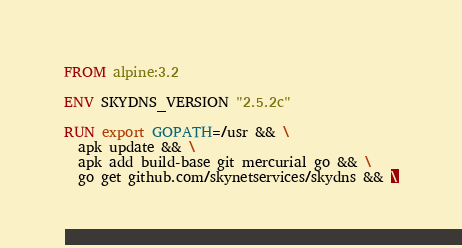<code> <loc_0><loc_0><loc_500><loc_500><_Dockerfile_>FROM alpine:3.2

ENV SKYDNS_VERSION "2.5.2c"

RUN export GOPATH=/usr && \
  apk update && \
  apk add build-base git mercurial go && \
  go get github.com/skynetservices/skydns && \</code> 